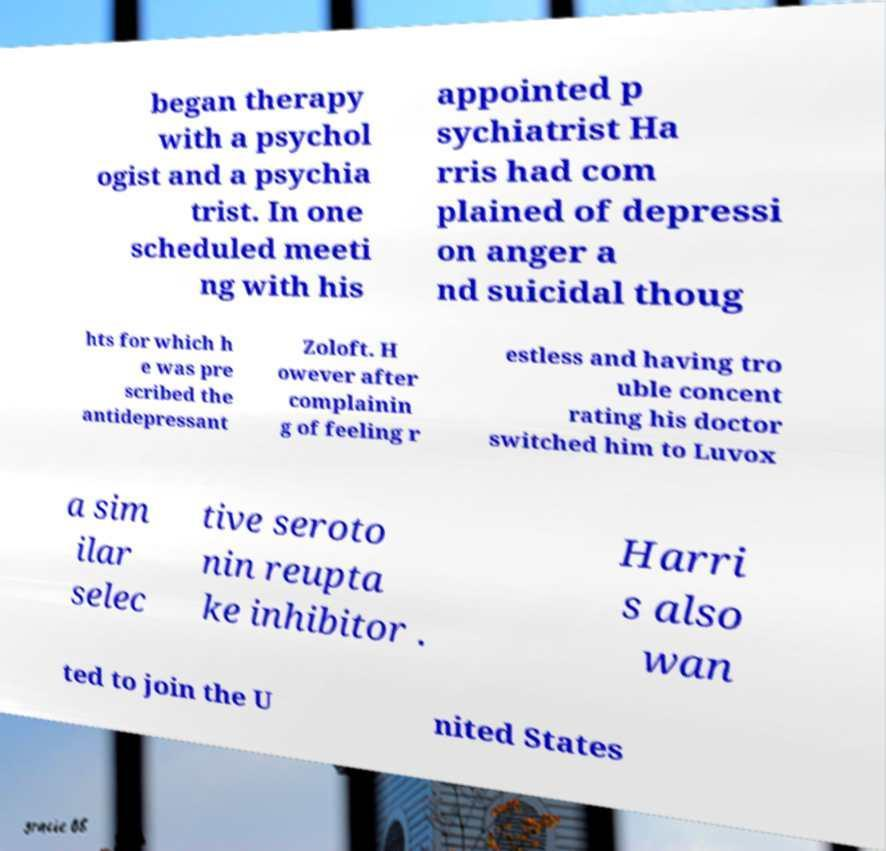Could you assist in decoding the text presented in this image and type it out clearly? began therapy with a psychol ogist and a psychia trist. In one scheduled meeti ng with his appointed p sychiatrist Ha rris had com plained of depressi on anger a nd suicidal thoug hts for which h e was pre scribed the antidepressant Zoloft. H owever after complainin g of feeling r estless and having tro uble concent rating his doctor switched him to Luvox a sim ilar selec tive seroto nin reupta ke inhibitor . Harri s also wan ted to join the U nited States 